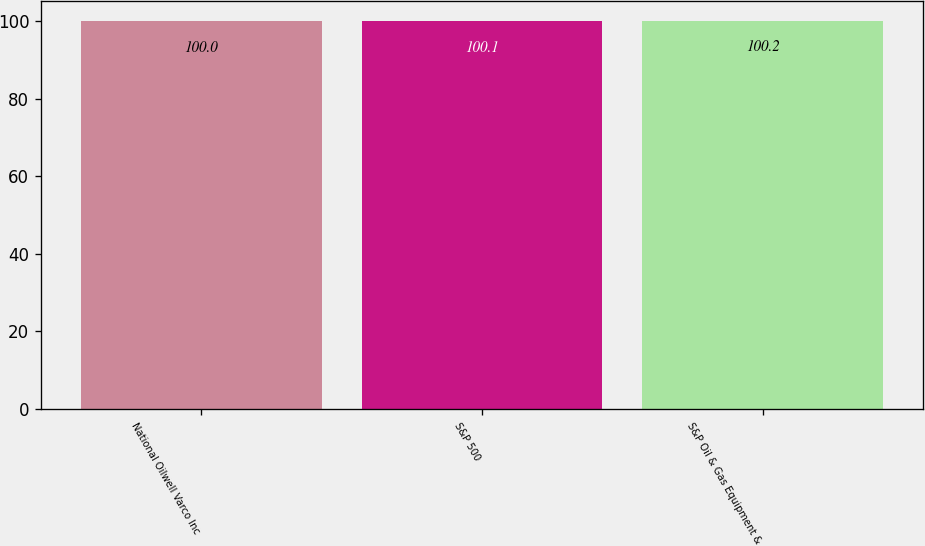Convert chart to OTSL. <chart><loc_0><loc_0><loc_500><loc_500><bar_chart><fcel>National Oilwell Varco Inc<fcel>S&P 500<fcel>S&P Oil & Gas Equipment &<nl><fcel>100<fcel>100.1<fcel>100.2<nl></chart> 